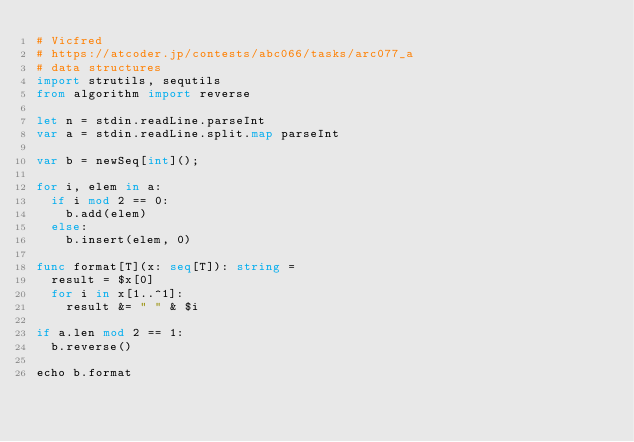Convert code to text. <code><loc_0><loc_0><loc_500><loc_500><_Nim_># Vicfred
# https://atcoder.jp/contests/abc066/tasks/arc077_a
# data structures
import strutils, sequtils
from algorithm import reverse

let n = stdin.readLine.parseInt
var a = stdin.readLine.split.map parseInt

var b = newSeq[int]();

for i, elem in a:
  if i mod 2 == 0:
    b.add(elem)
  else:
    b.insert(elem, 0)

func format[T](x: seq[T]): string =
  result = $x[0]
  for i in x[1..^1]:
    result &= " " & $i

if a.len mod 2 == 1:
  b.reverse()

echo b.format
</code> 